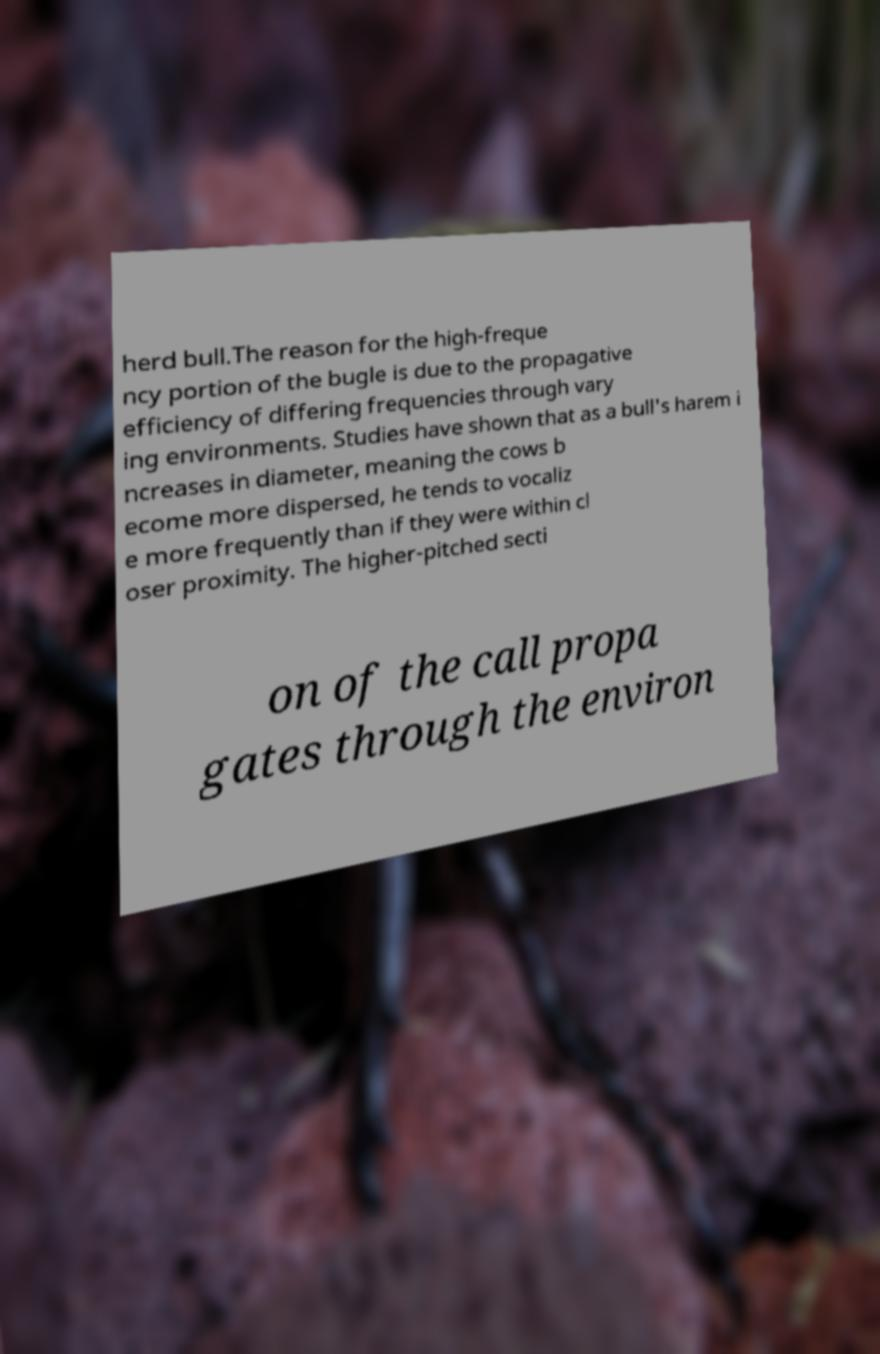Can you read and provide the text displayed in the image?This photo seems to have some interesting text. Can you extract and type it out for me? herd bull.The reason for the high-freque ncy portion of the bugle is due to the propagative efficiency of differing frequencies through vary ing environments. Studies have shown that as a bull's harem i ncreases in diameter, meaning the cows b ecome more dispersed, he tends to vocaliz e more frequently than if they were within cl oser proximity. The higher-pitched secti on of the call propa gates through the environ 